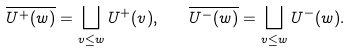Convert formula to latex. <formula><loc_0><loc_0><loc_500><loc_500>\overline { U ^ { + } ( w ) } = \bigsqcup _ { v \leq w } U ^ { + } ( v ) , \quad \overline { U ^ { - } ( w ) } = \bigsqcup _ { v \leq w } U ^ { - } ( w ) .</formula> 